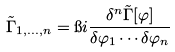Convert formula to latex. <formula><loc_0><loc_0><loc_500><loc_500>\tilde { \Gamma } _ { 1 , \dots , n } = \i i \frac { \delta ^ { n } \tilde { \Gamma } [ \varphi ] } { \delta \varphi _ { 1 } \cdots \delta \varphi _ { n } }</formula> 